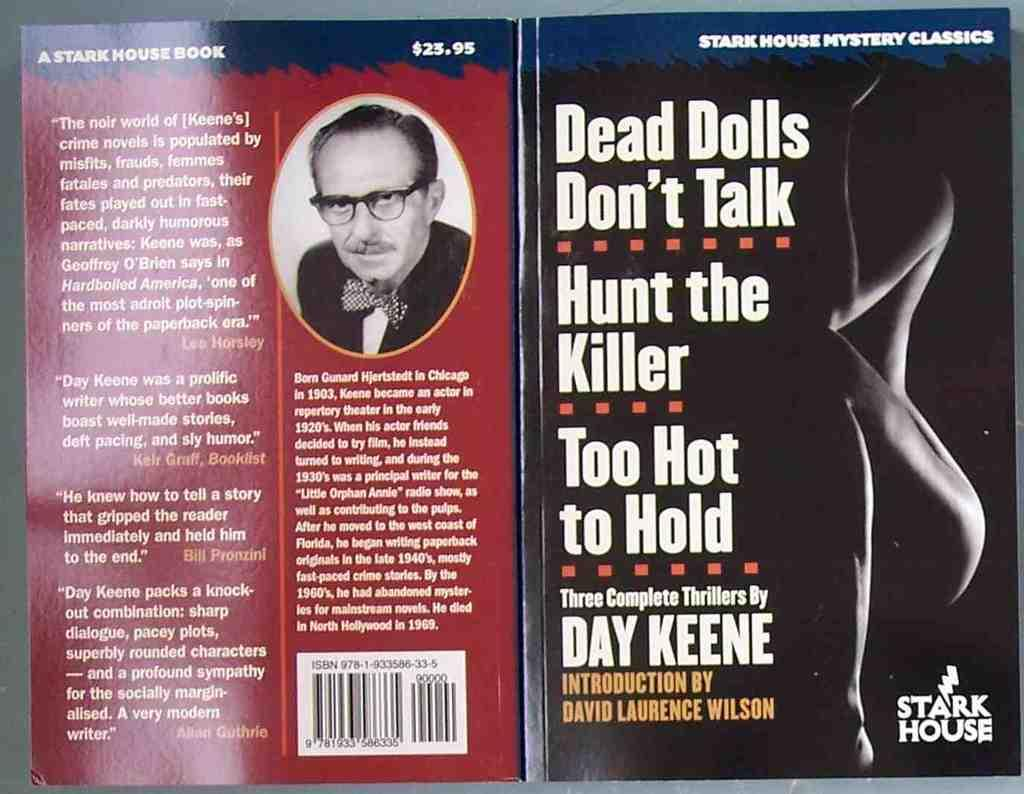<image>
Share a concise interpretation of the image provided. The front and back covers of a collection of three books by Day Keene. 